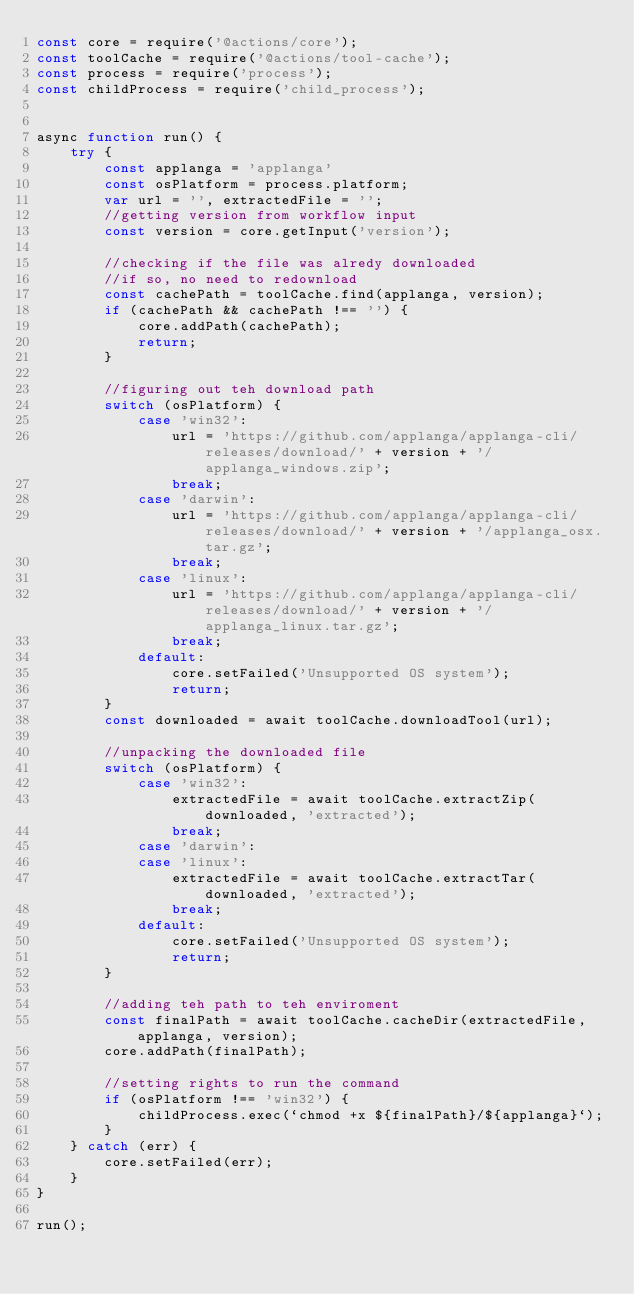<code> <loc_0><loc_0><loc_500><loc_500><_JavaScript_>const core = require('@actions/core');
const toolCache = require('@actions/tool-cache');
const process = require('process');
const childProcess = require('child_process');


async function run() {
	try {
		const applanga = 'applanga'
		const osPlatform = process.platform;
		var url = '', extractedFile = '';
		//getting version from workflow input
		const version = core.getInput('version');

		//checking if the file was alredy downloaded
		//if so, no need to redownload 
		const cachePath = toolCache.find(applanga, version);
		if (cachePath && cachePath !== '') {
			core.addPath(cachePath);
			return;
		}

		//figuring out teh download path
		switch (osPlatform) {
			case 'win32':
				url = 'https://github.com/applanga/applanga-cli/releases/download/' + version + '/applanga_windows.zip';
				break;
			case 'darwin':
				url = 'https://github.com/applanga/applanga-cli/releases/download/' + version + '/applanga_osx.tar.gz';
				break;
			case 'linux':
				url = 'https://github.com/applanga/applanga-cli/releases/download/' + version + '/applanga_linux.tar.gz';
				break;
			default:
				core.setFailed('Unsupported OS system');
				return;
		}
		const downloaded = await toolCache.downloadTool(url);

		//unpacking the downloaded file
		switch (osPlatform) {
			case 'win32':
				extractedFile = await toolCache.extractZip(downloaded, 'extracted');
				break;
			case 'darwin':
			case 'linux':
				extractedFile = await toolCache.extractTar(downloaded, 'extracted');
				break;
			default:
				core.setFailed('Unsupported OS system');
				return;
		}

		//adding teh path to teh enviroment
		const finalPath = await toolCache.cacheDir(extractedFile, applanga, version);
		core.addPath(finalPath);

		//setting rights to run the command
		if (osPlatform !== 'win32') {
			childProcess.exec(`chmod +x ${finalPath}/${applanga}`);
		}
	} catch (err) {
		core.setFailed(err);
	}
}

run();
</code> 